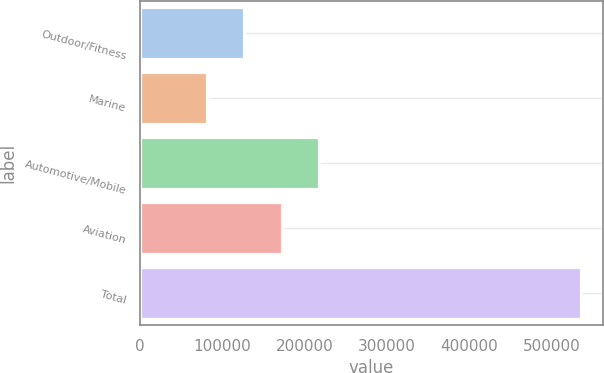Convert chart. <chart><loc_0><loc_0><loc_500><loc_500><bar_chart><fcel>Outdoor/Fitness<fcel>Marine<fcel>Automotive/Mobile<fcel>Aviation<fcel>Total<nl><fcel>126363<fcel>80951<fcel>217187<fcel>171775<fcel>535070<nl></chart> 